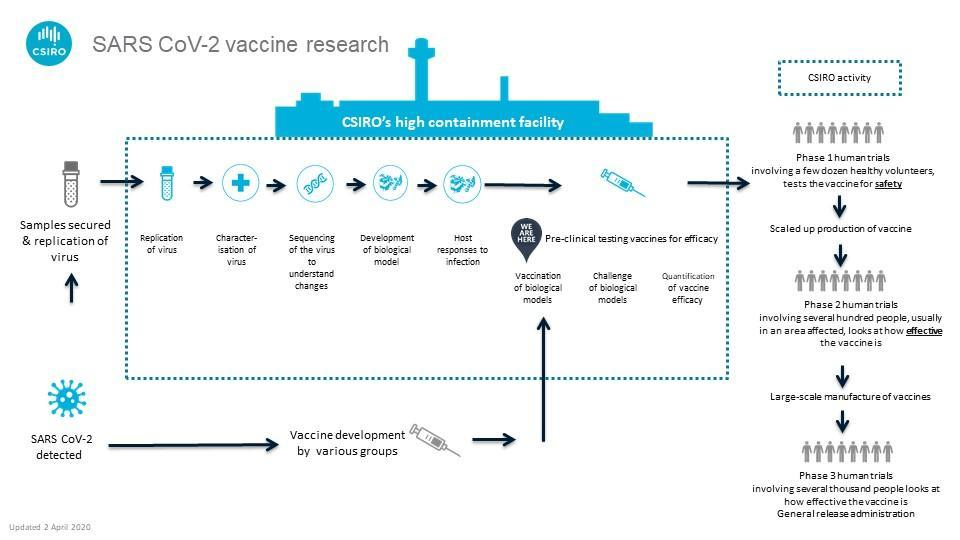How many test tubes are in this infographic?
Answer the question with a short phrase. 2 How many needles are in this infographic? 2 